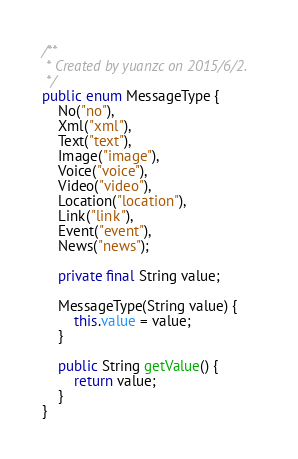Convert code to text. <code><loc_0><loc_0><loc_500><loc_500><_Java_>/**
 * Created by yuanzc on 2015/6/2.
 */
public enum MessageType {
    No("no"),
    Xml("xml"),
    Text("text"),
    Image("image"),
    Voice("voice"),
    Video("video"),
    Location("location"),
    Link("link"),
    Event("event"),
    News("news");

    private final String value;

    MessageType(String value) {
        this.value = value;
    }

    public String getValue() {
        return value;
    }
}
</code> 